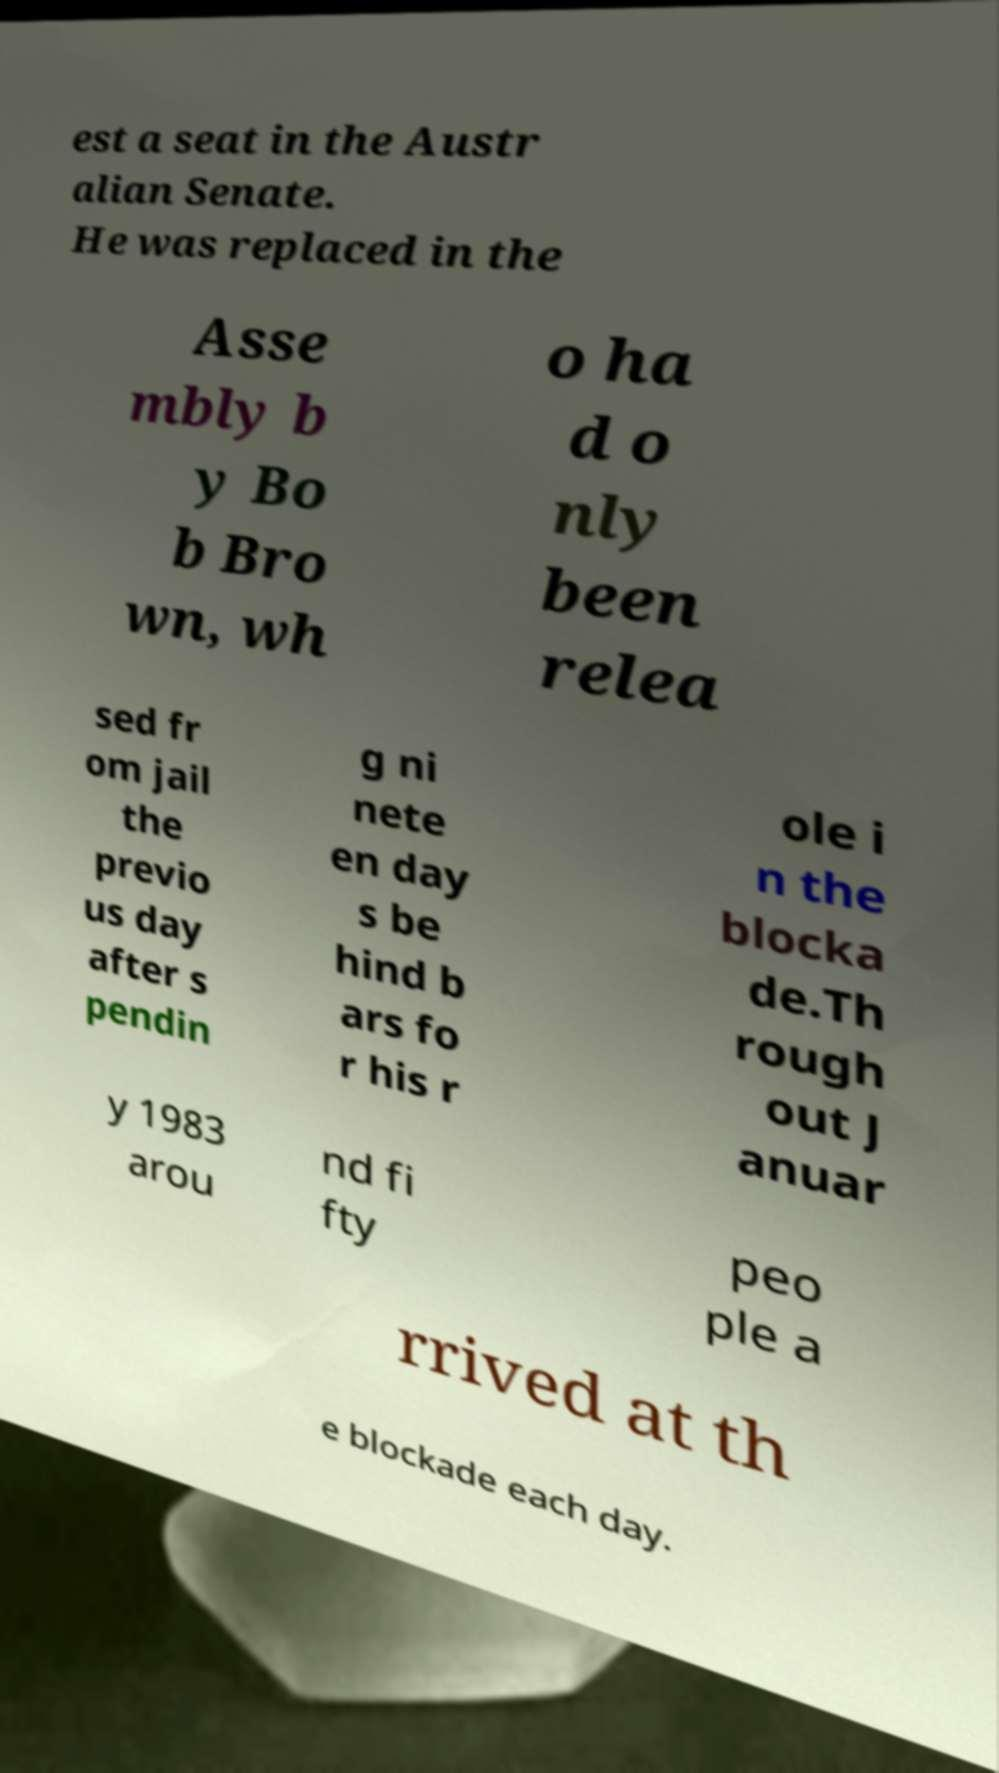Could you assist in decoding the text presented in this image and type it out clearly? est a seat in the Austr alian Senate. He was replaced in the Asse mbly b y Bo b Bro wn, wh o ha d o nly been relea sed fr om jail the previo us day after s pendin g ni nete en day s be hind b ars fo r his r ole i n the blocka de.Th rough out J anuar y 1983 arou nd fi fty peo ple a rrived at th e blockade each day. 